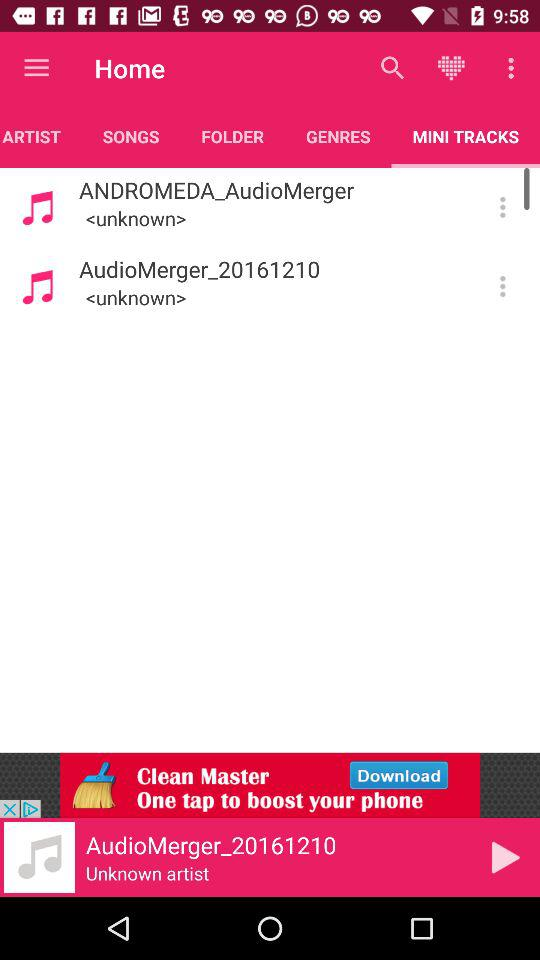What is the type of track? The type of track is "MINI". 